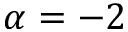<formula> <loc_0><loc_0><loc_500><loc_500>\alpha = - 2</formula> 